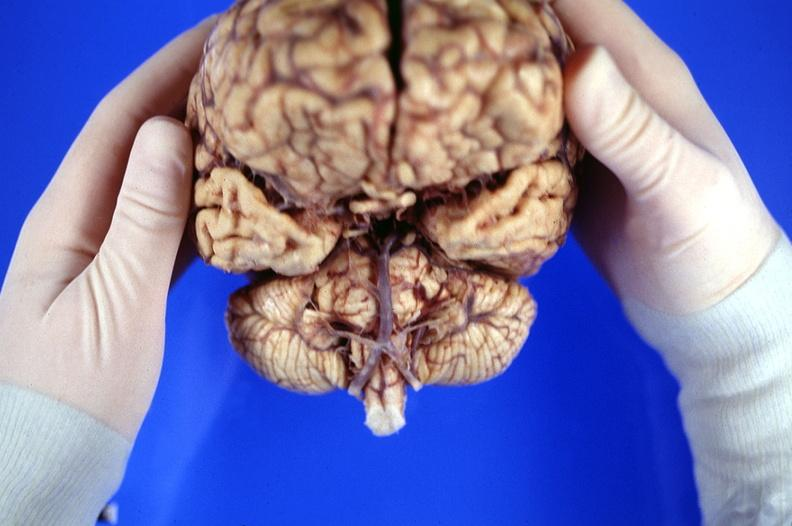what is present?
Answer the question using a single word or phrase. Nervous 